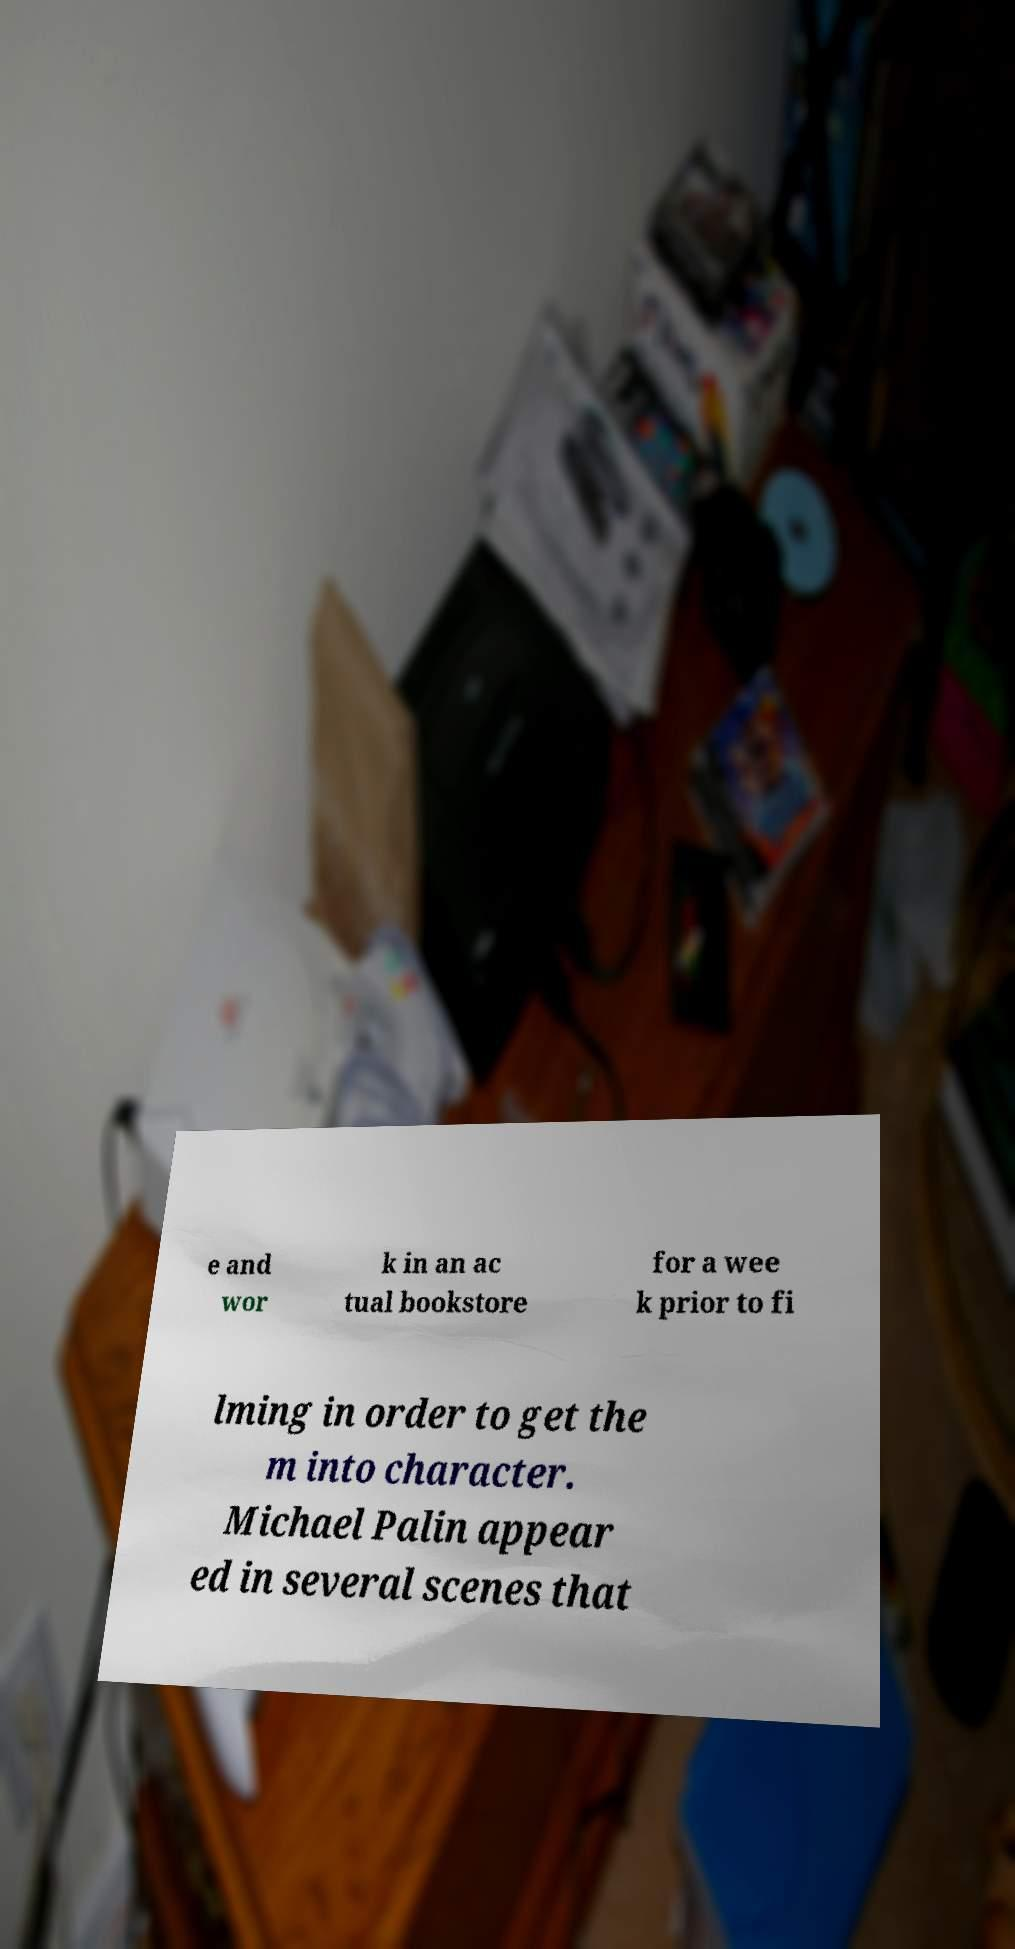Can you read and provide the text displayed in the image?This photo seems to have some interesting text. Can you extract and type it out for me? e and wor k in an ac tual bookstore for a wee k prior to fi lming in order to get the m into character. Michael Palin appear ed in several scenes that 